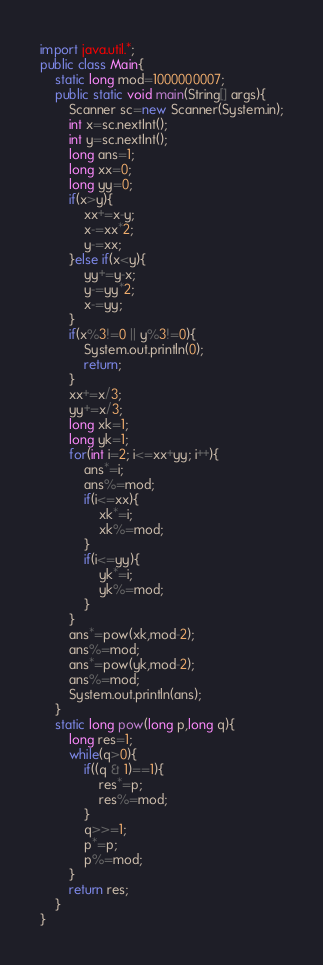Convert code to text. <code><loc_0><loc_0><loc_500><loc_500><_Java_>import java.util.*;
public class Main{
	static long mod=1000000007;
	public static void main(String[] args){
		Scanner sc=new Scanner(System.in);
		int x=sc.nextInt();
		int y=sc.nextInt();
		long ans=1;
		long xx=0;
		long yy=0;
		if(x>y){
			xx+=x-y;
			x-=xx*2;
			y-=xx;
		}else if(x<y){
			yy+=y-x;
			y-=yy*2;
			x-=yy;
		}
		if(x%3!=0 || y%3!=0){
			System.out.println(0);
			return;
		}
		xx+=x/3;
		yy+=x/3;
		long xk=1;
		long yk=1;
		for(int i=2; i<=xx+yy; i++){
			ans*=i;
			ans%=mod;
			if(i<=xx){
				xk*=i;
				xk%=mod;
			}
			if(i<=yy){
				yk*=i;
				yk%=mod;
			}
		}
		ans*=pow(xk,mod-2);
		ans%=mod;
		ans*=pow(yk,mod-2);
		ans%=mod;
		System.out.println(ans);
	}
	static long pow(long p,long q){
		long res=1;
		while(q>0){
			if((q & 1)==1){
				res*=p;
				res%=mod;
			}
			q>>=1;
			p*=p;
			p%=mod;
		}
		return res;
	}
}
</code> 